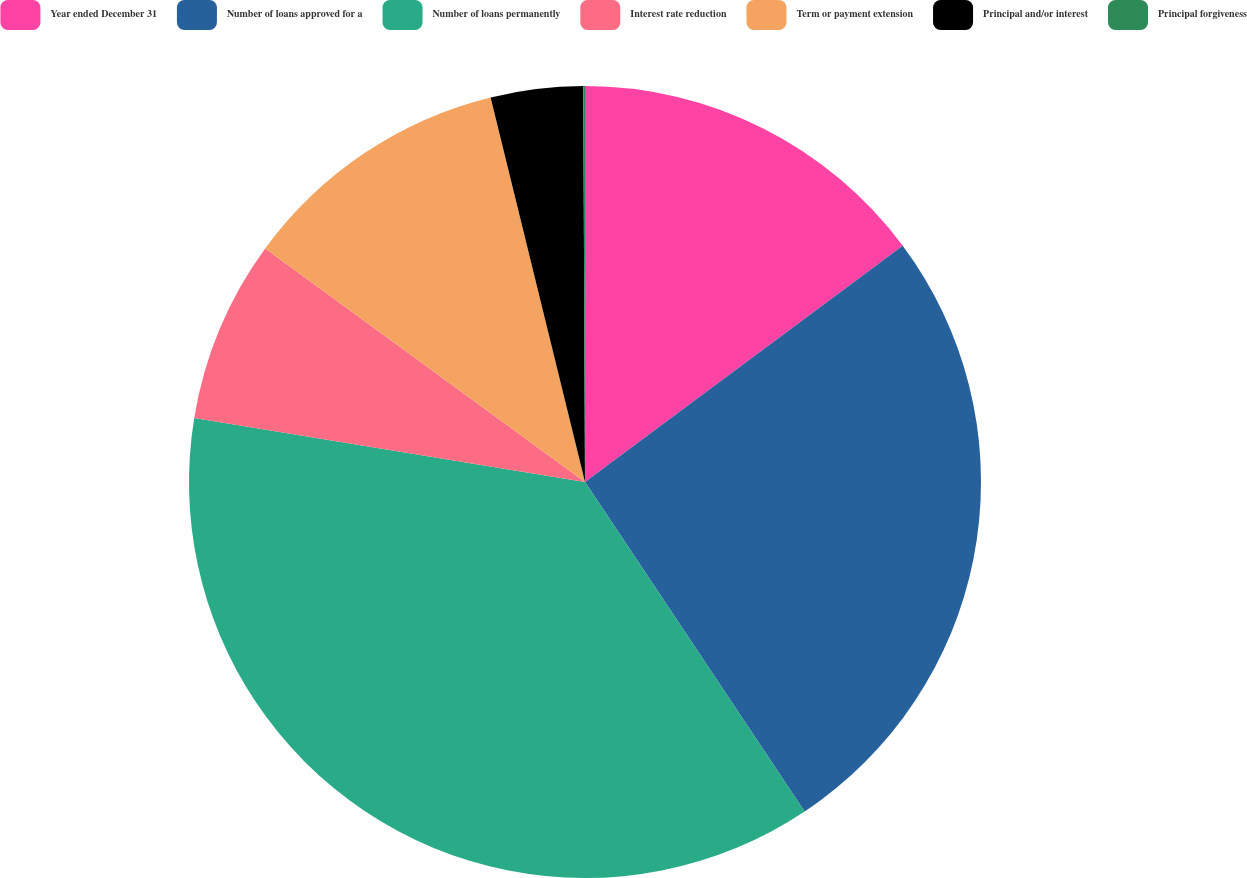Convert chart to OTSL. <chart><loc_0><loc_0><loc_500><loc_500><pie_chart><fcel>Year ended December 31<fcel>Number of loans approved for a<fcel>Number of loans permanently<fcel>Interest rate reduction<fcel>Term or payment extension<fcel>Principal and/or interest<fcel>Principal forgiveness<nl><fcel>14.82%<fcel>25.82%<fcel>36.94%<fcel>7.45%<fcel>11.13%<fcel>3.76%<fcel>0.07%<nl></chart> 